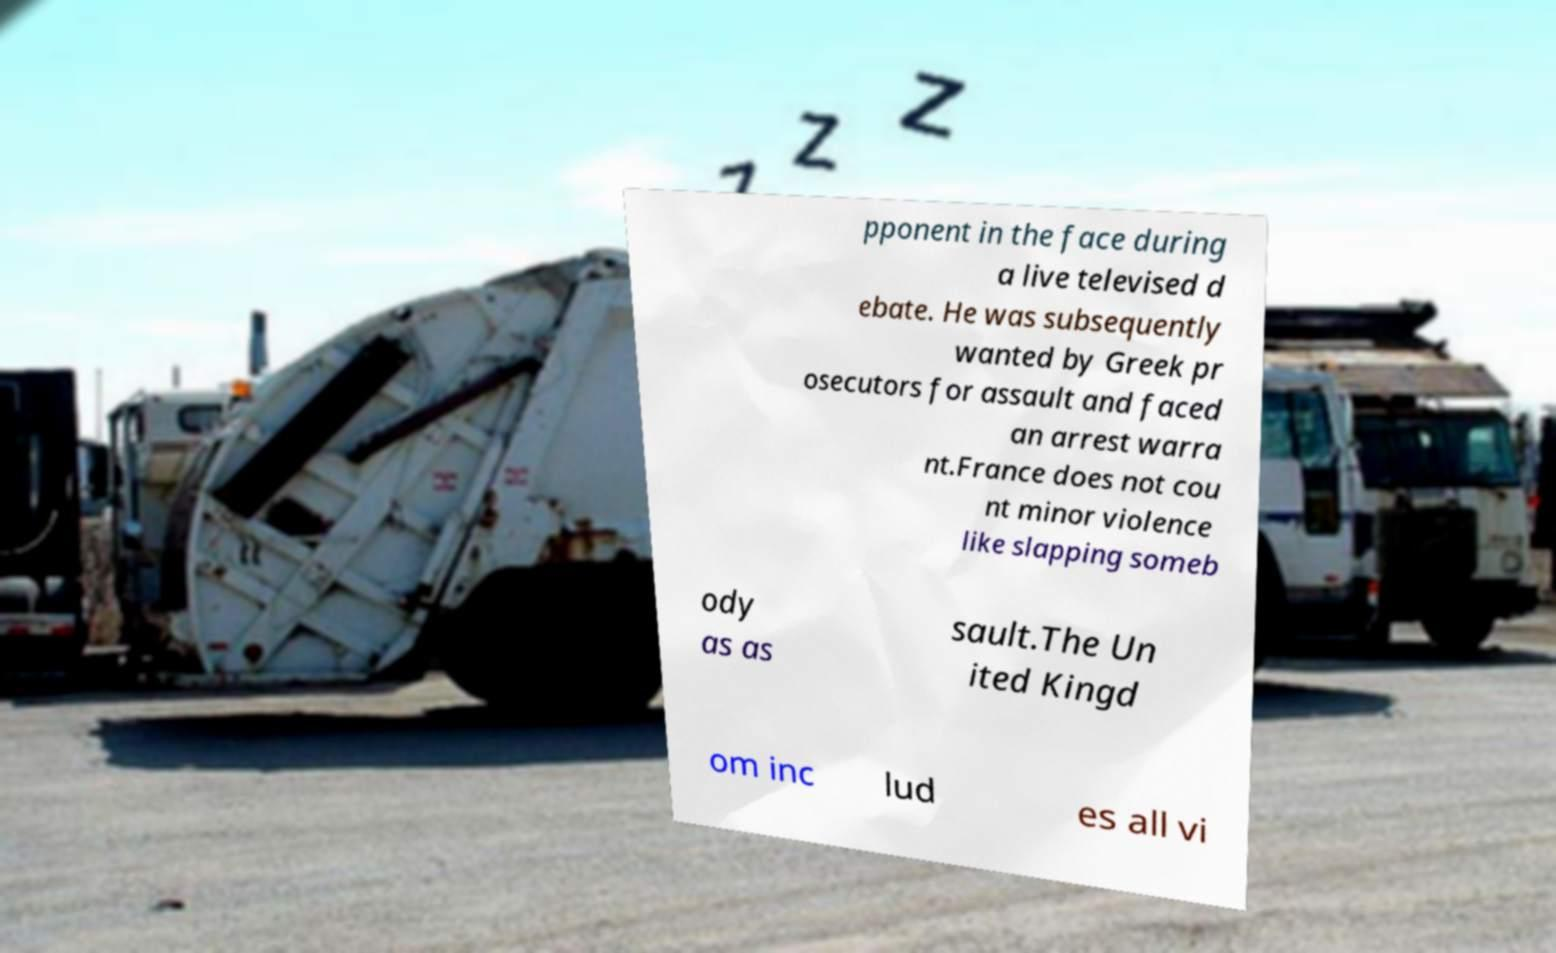Can you accurately transcribe the text from the provided image for me? pponent in the face during a live televised d ebate. He was subsequently wanted by Greek pr osecutors for assault and faced an arrest warra nt.France does not cou nt minor violence like slapping someb ody as as sault.The Un ited Kingd om inc lud es all vi 